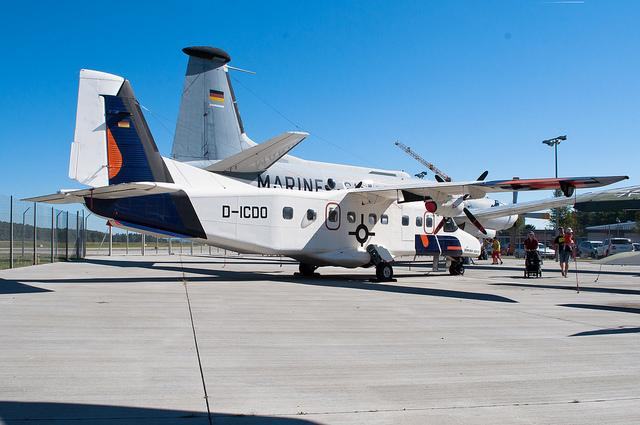What top speed can this vehicle likely reach? Please explain your reasoning. 1000 mph. These airplanes could most likely reach only 1000 miles per hour. 